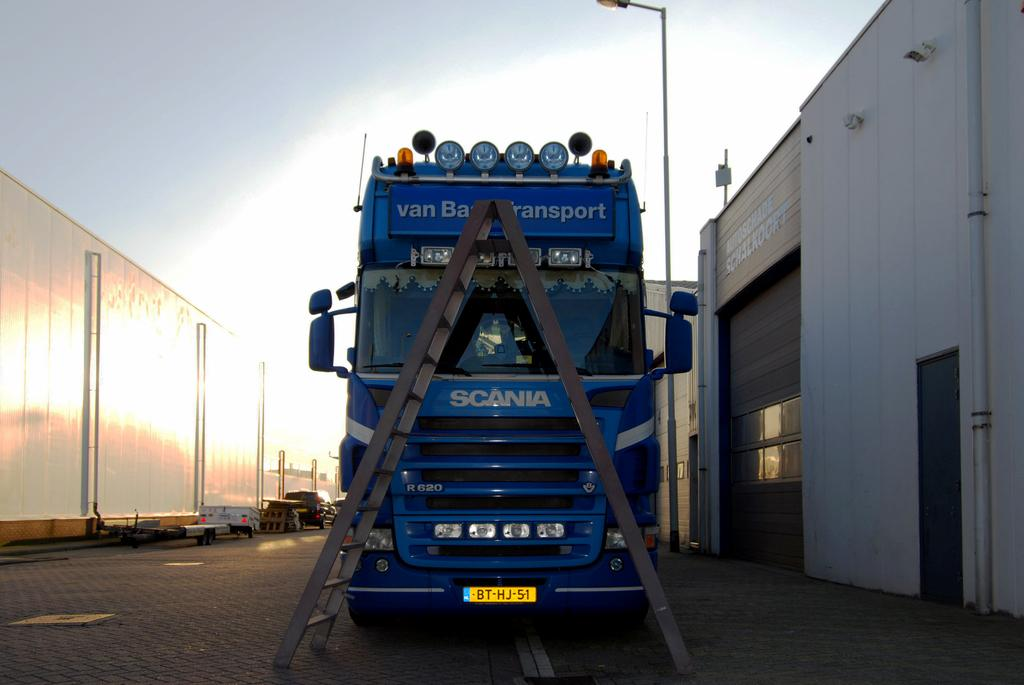What type of vehicle is on the road in the image? There is a truck on the road in the image. What is placed in front of the truck? There is a ladder in front of the truck. What can be seen on either side of the truck? There are buildings and lamp posts on either side of the truck. What type of donkey is pulling the truck in the image? There is no donkey present in the image, and the truck is not being pulled by any animal. 